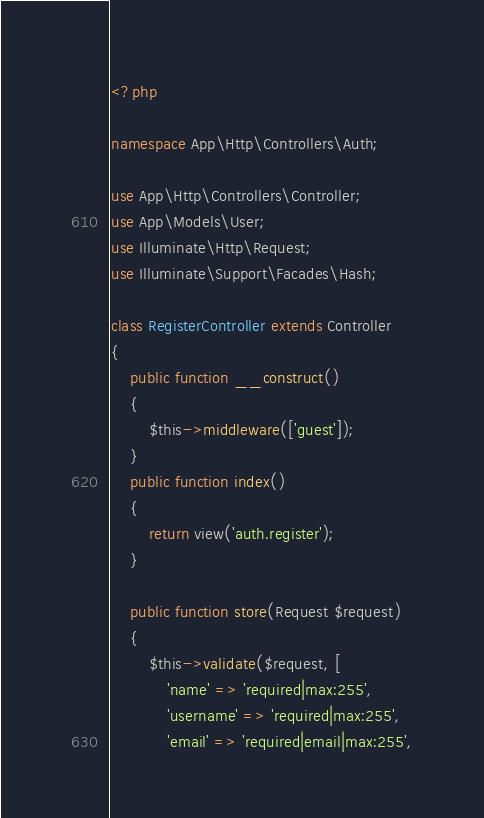Convert code to text. <code><loc_0><loc_0><loc_500><loc_500><_PHP_><?php

namespace App\Http\Controllers\Auth;

use App\Http\Controllers\Controller;
use App\Models\User;
use Illuminate\Http\Request;
use Illuminate\Support\Facades\Hash;

class RegisterController extends Controller
{
    public function __construct()
    {
        $this->middleware(['guest']);
    }
    public function index()
    {
        return view('auth.register');
    }

    public function store(Request $request)
    {
        $this->validate($request, [
            'name' => 'required|max:255',
            'username' => 'required|max:255',
            'email' => 'required|email|max:255',</code> 